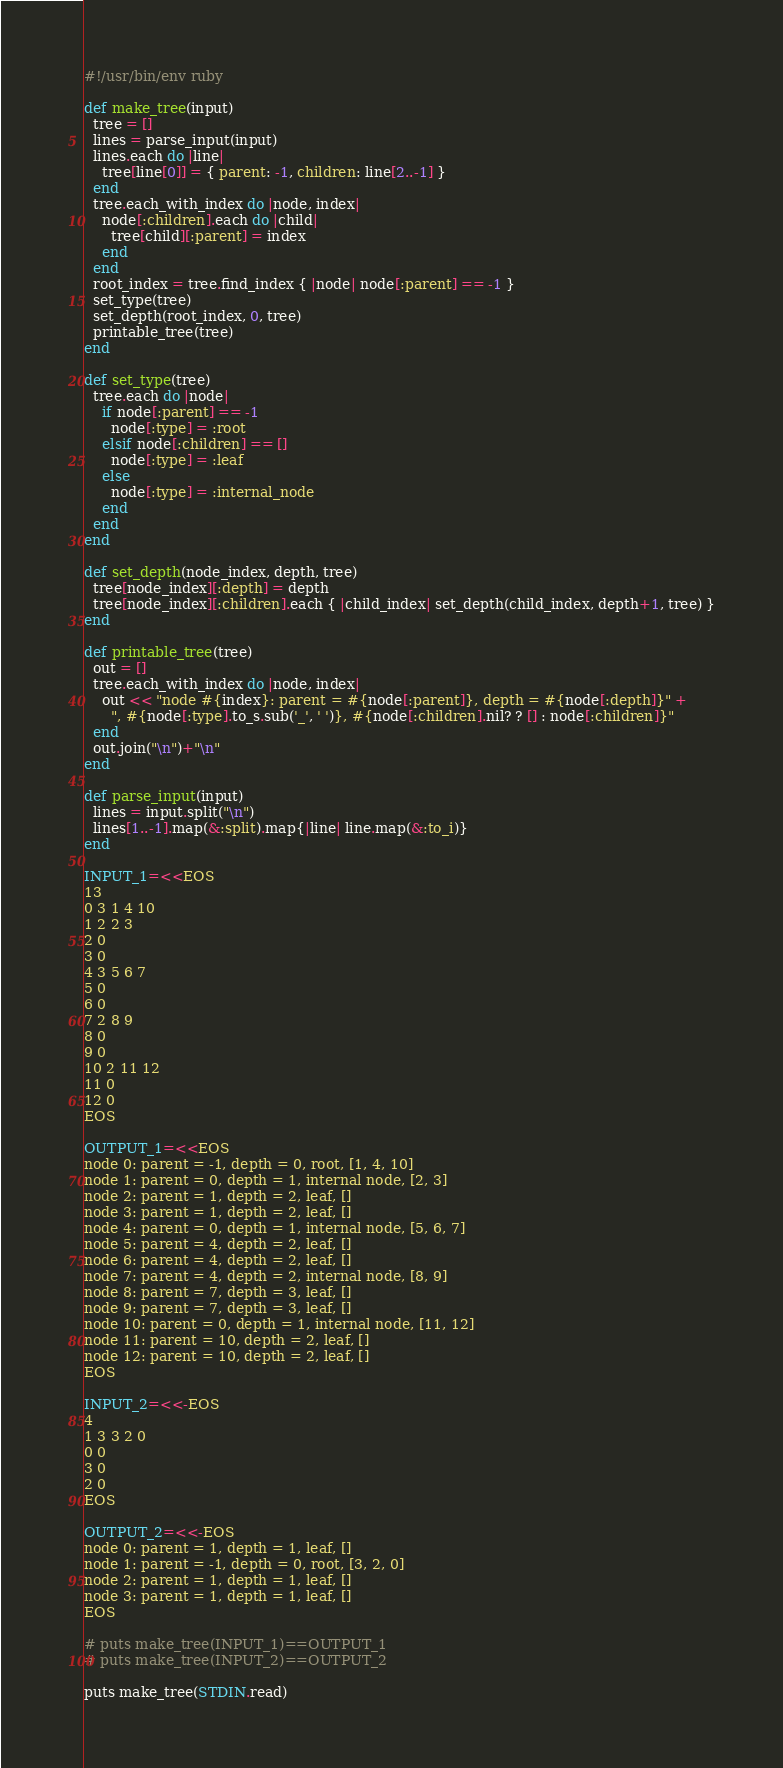Convert code to text. <code><loc_0><loc_0><loc_500><loc_500><_Ruby_>#!/usr/bin/env ruby

def make_tree(input)
  tree = []
  lines = parse_input(input)
  lines.each do |line|
    tree[line[0]] = { parent: -1, children: line[2..-1] }
  end
  tree.each_with_index do |node, index|
    node[:children].each do |child|
      tree[child][:parent] = index
    end
  end
  root_index = tree.find_index { |node| node[:parent] == -1 }
  set_type(tree)
  set_depth(root_index, 0, tree)
  printable_tree(tree)
end

def set_type(tree)
  tree.each do |node|
    if node[:parent] == -1
      node[:type] = :root 
    elsif node[:children] == []
      node[:type] = :leaf
    else 
      node[:type] = :internal_node
    end
  end
end

def set_depth(node_index, depth, tree)
  tree[node_index][:depth] = depth
  tree[node_index][:children].each { |child_index| set_depth(child_index, depth+1, tree) }
end

def printable_tree(tree)
  out = []
  tree.each_with_index do |node, index|
    out << "node #{index}: parent = #{node[:parent]}, depth = #{node[:depth]}" +
      ", #{node[:type].to_s.sub('_', ' ')}, #{node[:children].nil? ? [] : node[:children]}"
  end
  out.join("\n")+"\n"
end

def parse_input(input)
  lines = input.split("\n")
  lines[1..-1].map(&:split).map{|line| line.map(&:to_i)}
end

INPUT_1=<<EOS
13
0 3 1 4 10
1 2 2 3
2 0
3 0
4 3 5 6 7
5 0
6 0
7 2 8 9
8 0
9 0
10 2 11 12
11 0
12 0
EOS

OUTPUT_1=<<EOS
node 0: parent = -1, depth = 0, root, [1, 4, 10]
node 1: parent = 0, depth = 1, internal node, [2, 3]
node 2: parent = 1, depth = 2, leaf, []
node 3: parent = 1, depth = 2, leaf, []
node 4: parent = 0, depth = 1, internal node, [5, 6, 7]
node 5: parent = 4, depth = 2, leaf, []
node 6: parent = 4, depth = 2, leaf, []
node 7: parent = 4, depth = 2, internal node, [8, 9]
node 8: parent = 7, depth = 3, leaf, []
node 9: parent = 7, depth = 3, leaf, []
node 10: parent = 0, depth = 1, internal node, [11, 12]
node 11: parent = 10, depth = 2, leaf, []
node 12: parent = 10, depth = 2, leaf, []
EOS

INPUT_2=<<-EOS
4
1 3 3 2 0
0 0
3 0
2 0
EOS

OUTPUT_2=<<-EOS
node 0: parent = 1, depth = 1, leaf, []
node 1: parent = -1, depth = 0, root, [3, 2, 0]
node 2: parent = 1, depth = 1, leaf, []
node 3: parent = 1, depth = 1, leaf, []
EOS

# puts make_tree(INPUT_1)==OUTPUT_1
# puts make_tree(INPUT_2)==OUTPUT_2

puts make_tree(STDIN.read)</code> 